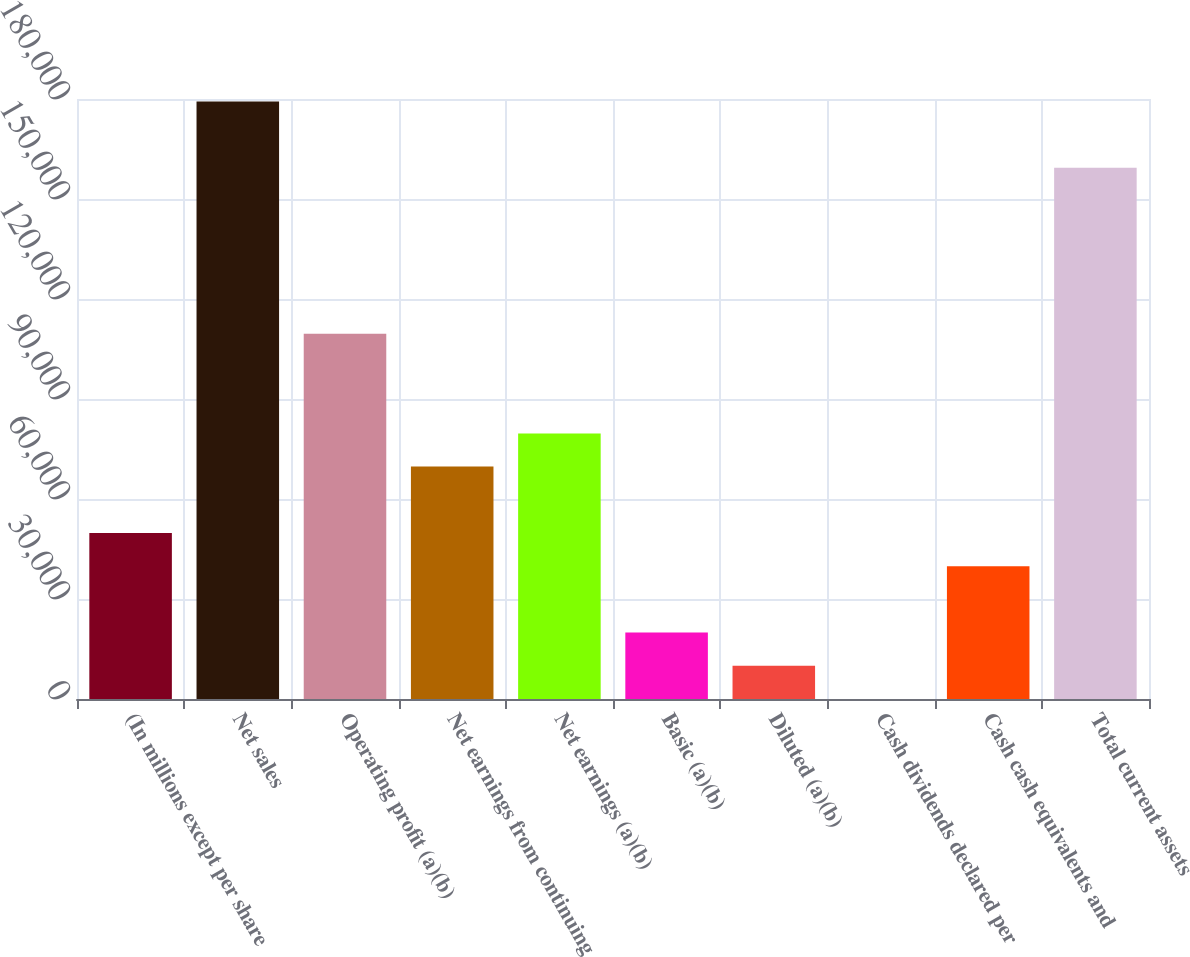<chart> <loc_0><loc_0><loc_500><loc_500><bar_chart><fcel>(In millions except per share<fcel>Net sales<fcel>Operating profit (a)(b)<fcel>Net earnings from continuing<fcel>Net earnings (a)(b)<fcel>Basic (a)(b)<fcel>Diluted (a)(b)<fcel>Cash dividends declared per<fcel>Cash cash equivalents and<fcel>Total current assets<nl><fcel>49803.1<fcel>179275<fcel>109559<fcel>69721.9<fcel>79681.3<fcel>19924.9<fcel>9965.54<fcel>6.15<fcel>39843.7<fcel>159356<nl></chart> 